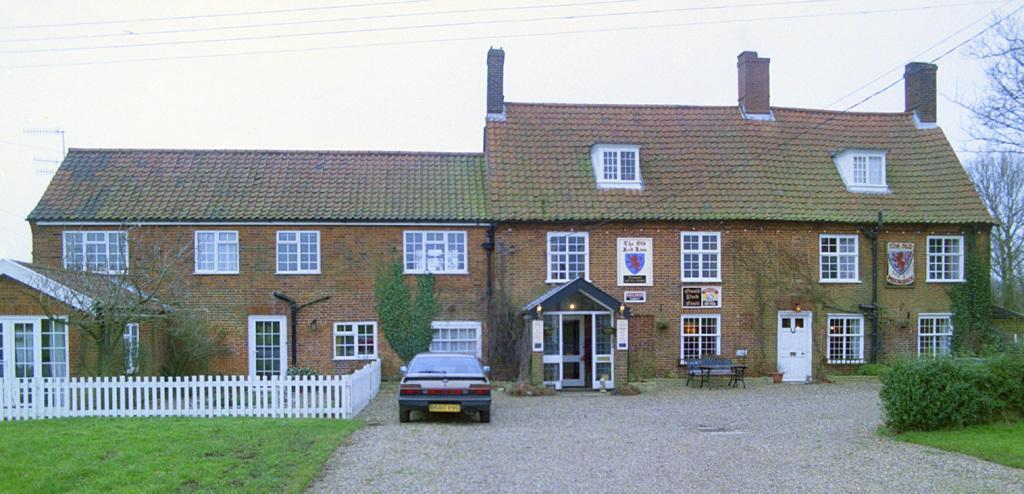Could you give a brief overview of what you see in this image? In this image we can see a house, there are windows, doors, pipes, lights, there is a fencing, a car, there are plants, grass, trees, a bench, and a table, also we can see the sky. 